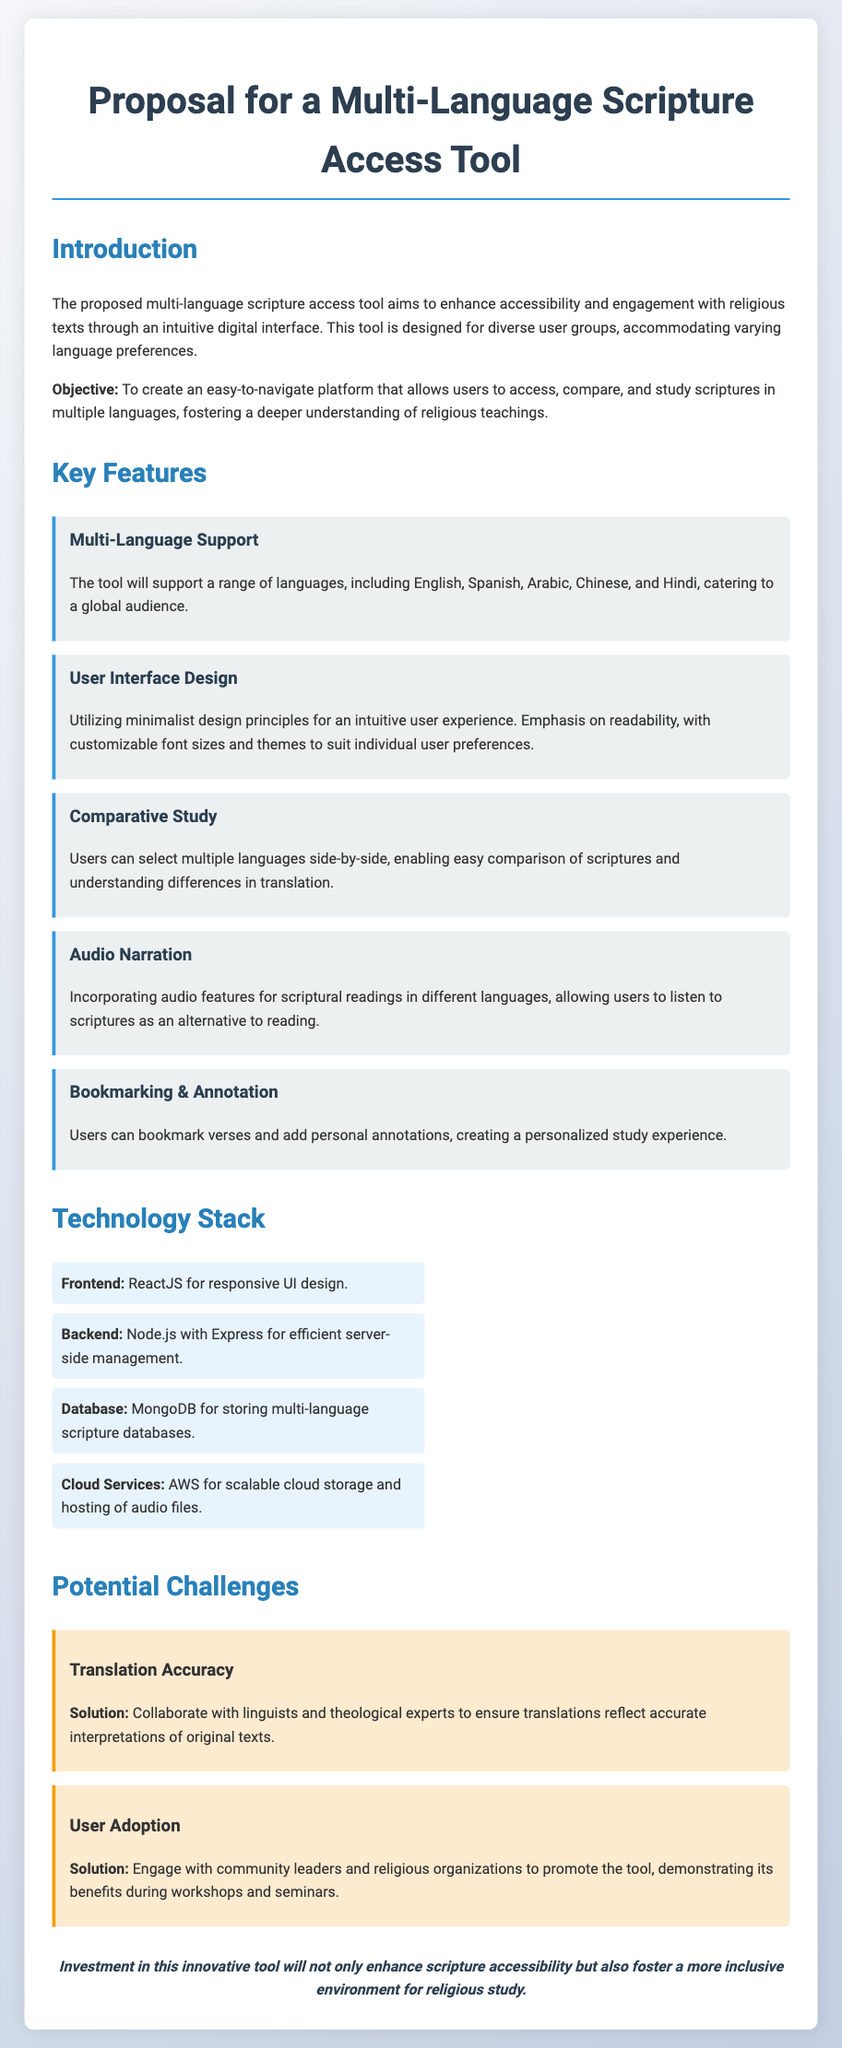What is the objective of the tool? The objective of the tool is to create an easy-to-navigate platform that allows users to access, compare, and study scriptures in multiple languages, fostering a deeper understanding of religious teachings.
Answer: Easy-to-navigate platform for scripture access, comparison, and study How many languages does the tool support? The document mentions specific languages supported by the tool, which are English, Spanish, Arabic, Chinese, and Hindi.
Answer: Five languages What technology is used for the frontend? The document specifically states the frontend technology used to create the user interface of the tool.
Answer: ReactJS What is one feature of the audio narration? The audio narration feature allows users to listen to scriptures as an alternative to reading, providing an added experience in different languages.
Answer: Listen to scriptures What potential challenge is associated with user adoption? The document highlights potential challenges related to promoting the tool to ensure its use among target audiences.
Answer: User Adoption What is the solution for translation accuracy? The document outlines a specific approach for ensuring translation accuracy while developing the tool.
Answer: Collaborate with linguists and theological experts How is the user interface designed? The document describes the design philosophy behind the user interface which underlines key aspects intended for user experience.
Answer: Minimalist design principles 